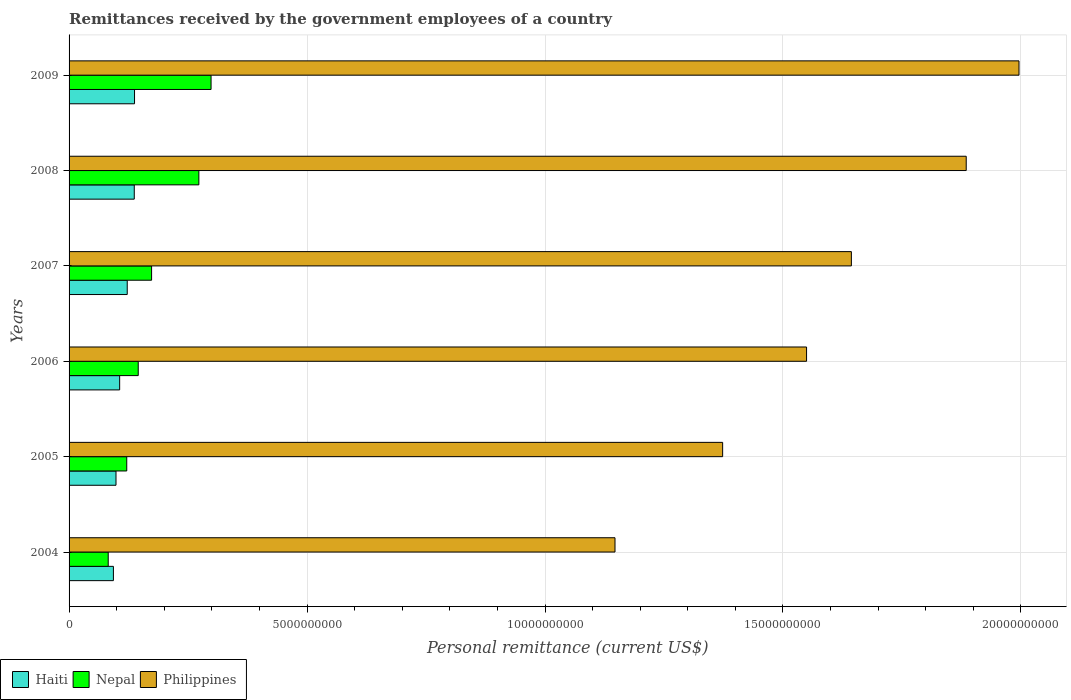Are the number of bars on each tick of the Y-axis equal?
Make the answer very short. Yes. How many bars are there on the 5th tick from the bottom?
Your answer should be compact. 3. What is the label of the 1st group of bars from the top?
Provide a short and direct response. 2009. What is the remittances received by the government employees in Philippines in 2005?
Offer a terse response. 1.37e+1. Across all years, what is the maximum remittances received by the government employees in Haiti?
Keep it short and to the point. 1.38e+09. Across all years, what is the minimum remittances received by the government employees in Haiti?
Give a very brief answer. 9.32e+08. In which year was the remittances received by the government employees in Philippines maximum?
Your answer should be very brief. 2009. In which year was the remittances received by the government employees in Philippines minimum?
Make the answer very short. 2004. What is the total remittances received by the government employees in Nepal in the graph?
Keep it short and to the point. 1.09e+1. What is the difference between the remittances received by the government employees in Haiti in 2007 and that in 2008?
Provide a succinct answer. -1.48e+08. What is the difference between the remittances received by the government employees in Haiti in 2006 and the remittances received by the government employees in Nepal in 2008?
Offer a very short reply. -1.66e+09. What is the average remittances received by the government employees in Nepal per year?
Give a very brief answer. 1.82e+09. In the year 2006, what is the difference between the remittances received by the government employees in Philippines and remittances received by the government employees in Haiti?
Make the answer very short. 1.44e+1. What is the ratio of the remittances received by the government employees in Nepal in 2005 to that in 2007?
Provide a short and direct response. 0.7. Is the difference between the remittances received by the government employees in Philippines in 2005 and 2009 greater than the difference between the remittances received by the government employees in Haiti in 2005 and 2009?
Offer a terse response. No. What is the difference between the highest and the second highest remittances received by the government employees in Haiti?
Provide a short and direct response. 5.79e+06. What is the difference between the highest and the lowest remittances received by the government employees in Nepal?
Make the answer very short. 2.16e+09. What does the 3rd bar from the top in 2006 represents?
Your response must be concise. Haiti. What does the 3rd bar from the bottom in 2004 represents?
Your answer should be compact. Philippines. How many bars are there?
Offer a terse response. 18. Are all the bars in the graph horizontal?
Provide a succinct answer. Yes. How many years are there in the graph?
Provide a succinct answer. 6. Where does the legend appear in the graph?
Provide a short and direct response. Bottom left. How are the legend labels stacked?
Your response must be concise. Horizontal. What is the title of the graph?
Offer a terse response. Remittances received by the government employees of a country. What is the label or title of the X-axis?
Your answer should be very brief. Personal remittance (current US$). What is the Personal remittance (current US$) of Haiti in 2004?
Provide a short and direct response. 9.32e+08. What is the Personal remittance (current US$) of Nepal in 2004?
Offer a terse response. 8.23e+08. What is the Personal remittance (current US$) of Philippines in 2004?
Provide a succinct answer. 1.15e+1. What is the Personal remittance (current US$) in Haiti in 2005?
Your response must be concise. 9.86e+08. What is the Personal remittance (current US$) in Nepal in 2005?
Provide a short and direct response. 1.21e+09. What is the Personal remittance (current US$) in Philippines in 2005?
Make the answer very short. 1.37e+1. What is the Personal remittance (current US$) of Haiti in 2006?
Your answer should be compact. 1.06e+09. What is the Personal remittance (current US$) of Nepal in 2006?
Keep it short and to the point. 1.45e+09. What is the Personal remittance (current US$) in Philippines in 2006?
Offer a very short reply. 1.55e+1. What is the Personal remittance (current US$) of Haiti in 2007?
Give a very brief answer. 1.22e+09. What is the Personal remittance (current US$) in Nepal in 2007?
Offer a very short reply. 1.73e+09. What is the Personal remittance (current US$) of Philippines in 2007?
Provide a short and direct response. 1.64e+1. What is the Personal remittance (current US$) in Haiti in 2008?
Offer a terse response. 1.37e+09. What is the Personal remittance (current US$) of Nepal in 2008?
Your answer should be compact. 2.73e+09. What is the Personal remittance (current US$) of Philippines in 2008?
Give a very brief answer. 1.89e+1. What is the Personal remittance (current US$) in Haiti in 2009?
Give a very brief answer. 1.38e+09. What is the Personal remittance (current US$) in Nepal in 2009?
Keep it short and to the point. 2.98e+09. What is the Personal remittance (current US$) in Philippines in 2009?
Provide a short and direct response. 2.00e+1. Across all years, what is the maximum Personal remittance (current US$) in Haiti?
Ensure brevity in your answer.  1.38e+09. Across all years, what is the maximum Personal remittance (current US$) in Nepal?
Offer a terse response. 2.98e+09. Across all years, what is the maximum Personal remittance (current US$) in Philippines?
Provide a succinct answer. 2.00e+1. Across all years, what is the minimum Personal remittance (current US$) of Haiti?
Your answer should be compact. 9.32e+08. Across all years, what is the minimum Personal remittance (current US$) in Nepal?
Make the answer very short. 8.23e+08. Across all years, what is the minimum Personal remittance (current US$) in Philippines?
Your answer should be very brief. 1.15e+1. What is the total Personal remittance (current US$) in Haiti in the graph?
Your answer should be very brief. 6.95e+09. What is the total Personal remittance (current US$) in Nepal in the graph?
Give a very brief answer. 1.09e+1. What is the total Personal remittance (current US$) of Philippines in the graph?
Give a very brief answer. 9.59e+1. What is the difference between the Personal remittance (current US$) in Haiti in 2004 and that in 2005?
Provide a succinct answer. -5.46e+07. What is the difference between the Personal remittance (current US$) in Nepal in 2004 and that in 2005?
Keep it short and to the point. -3.89e+08. What is the difference between the Personal remittance (current US$) in Philippines in 2004 and that in 2005?
Offer a terse response. -2.26e+09. What is the difference between the Personal remittance (current US$) in Haiti in 2004 and that in 2006?
Give a very brief answer. -1.31e+08. What is the difference between the Personal remittance (current US$) of Nepal in 2004 and that in 2006?
Give a very brief answer. -6.31e+08. What is the difference between the Personal remittance (current US$) of Philippines in 2004 and that in 2006?
Make the answer very short. -4.03e+09. What is the difference between the Personal remittance (current US$) in Haiti in 2004 and that in 2007?
Your answer should be compact. -2.91e+08. What is the difference between the Personal remittance (current US$) of Nepal in 2004 and that in 2007?
Ensure brevity in your answer.  -9.11e+08. What is the difference between the Personal remittance (current US$) of Philippines in 2004 and that in 2007?
Provide a succinct answer. -4.97e+09. What is the difference between the Personal remittance (current US$) of Haiti in 2004 and that in 2008?
Offer a very short reply. -4.38e+08. What is the difference between the Personal remittance (current US$) of Nepal in 2004 and that in 2008?
Offer a terse response. -1.90e+09. What is the difference between the Personal remittance (current US$) of Philippines in 2004 and that in 2008?
Ensure brevity in your answer.  -7.38e+09. What is the difference between the Personal remittance (current US$) in Haiti in 2004 and that in 2009?
Offer a very short reply. -4.44e+08. What is the difference between the Personal remittance (current US$) of Nepal in 2004 and that in 2009?
Your answer should be compact. -2.16e+09. What is the difference between the Personal remittance (current US$) in Philippines in 2004 and that in 2009?
Ensure brevity in your answer.  -8.49e+09. What is the difference between the Personal remittance (current US$) of Haiti in 2005 and that in 2006?
Ensure brevity in your answer.  -7.67e+07. What is the difference between the Personal remittance (current US$) of Nepal in 2005 and that in 2006?
Your answer should be very brief. -2.41e+08. What is the difference between the Personal remittance (current US$) of Philippines in 2005 and that in 2006?
Your answer should be very brief. -1.76e+09. What is the difference between the Personal remittance (current US$) in Haiti in 2005 and that in 2007?
Your answer should be very brief. -2.36e+08. What is the difference between the Personal remittance (current US$) in Nepal in 2005 and that in 2007?
Your response must be concise. -5.22e+08. What is the difference between the Personal remittance (current US$) of Philippines in 2005 and that in 2007?
Provide a short and direct response. -2.70e+09. What is the difference between the Personal remittance (current US$) in Haiti in 2005 and that in 2008?
Your answer should be very brief. -3.84e+08. What is the difference between the Personal remittance (current US$) of Nepal in 2005 and that in 2008?
Make the answer very short. -1.52e+09. What is the difference between the Personal remittance (current US$) of Philippines in 2005 and that in 2008?
Offer a very short reply. -5.12e+09. What is the difference between the Personal remittance (current US$) in Haiti in 2005 and that in 2009?
Your answer should be compact. -3.89e+08. What is the difference between the Personal remittance (current US$) of Nepal in 2005 and that in 2009?
Your answer should be very brief. -1.77e+09. What is the difference between the Personal remittance (current US$) of Philippines in 2005 and that in 2009?
Provide a succinct answer. -6.23e+09. What is the difference between the Personal remittance (current US$) in Haiti in 2006 and that in 2007?
Your answer should be very brief. -1.59e+08. What is the difference between the Personal remittance (current US$) in Nepal in 2006 and that in 2007?
Provide a short and direct response. -2.81e+08. What is the difference between the Personal remittance (current US$) in Philippines in 2006 and that in 2007?
Make the answer very short. -9.41e+08. What is the difference between the Personal remittance (current US$) in Haiti in 2006 and that in 2008?
Your response must be concise. -3.07e+08. What is the difference between the Personal remittance (current US$) in Nepal in 2006 and that in 2008?
Offer a very short reply. -1.27e+09. What is the difference between the Personal remittance (current US$) of Philippines in 2006 and that in 2008?
Keep it short and to the point. -3.35e+09. What is the difference between the Personal remittance (current US$) of Haiti in 2006 and that in 2009?
Your answer should be very brief. -3.13e+08. What is the difference between the Personal remittance (current US$) of Nepal in 2006 and that in 2009?
Offer a terse response. -1.53e+09. What is the difference between the Personal remittance (current US$) of Philippines in 2006 and that in 2009?
Offer a terse response. -4.46e+09. What is the difference between the Personal remittance (current US$) in Haiti in 2007 and that in 2008?
Offer a very short reply. -1.48e+08. What is the difference between the Personal remittance (current US$) of Nepal in 2007 and that in 2008?
Give a very brief answer. -9.93e+08. What is the difference between the Personal remittance (current US$) of Philippines in 2007 and that in 2008?
Offer a terse response. -2.41e+09. What is the difference between the Personal remittance (current US$) in Haiti in 2007 and that in 2009?
Offer a terse response. -1.53e+08. What is the difference between the Personal remittance (current US$) in Nepal in 2007 and that in 2009?
Make the answer very short. -1.25e+09. What is the difference between the Personal remittance (current US$) in Philippines in 2007 and that in 2009?
Your response must be concise. -3.52e+09. What is the difference between the Personal remittance (current US$) of Haiti in 2008 and that in 2009?
Provide a short and direct response. -5.79e+06. What is the difference between the Personal remittance (current US$) in Nepal in 2008 and that in 2009?
Keep it short and to the point. -2.56e+08. What is the difference between the Personal remittance (current US$) of Philippines in 2008 and that in 2009?
Your answer should be very brief. -1.11e+09. What is the difference between the Personal remittance (current US$) in Haiti in 2004 and the Personal remittance (current US$) in Nepal in 2005?
Provide a succinct answer. -2.80e+08. What is the difference between the Personal remittance (current US$) in Haiti in 2004 and the Personal remittance (current US$) in Philippines in 2005?
Provide a succinct answer. -1.28e+1. What is the difference between the Personal remittance (current US$) of Nepal in 2004 and the Personal remittance (current US$) of Philippines in 2005?
Keep it short and to the point. -1.29e+1. What is the difference between the Personal remittance (current US$) in Haiti in 2004 and the Personal remittance (current US$) in Nepal in 2006?
Offer a very short reply. -5.22e+08. What is the difference between the Personal remittance (current US$) of Haiti in 2004 and the Personal remittance (current US$) of Philippines in 2006?
Offer a terse response. -1.46e+1. What is the difference between the Personal remittance (current US$) in Nepal in 2004 and the Personal remittance (current US$) in Philippines in 2006?
Your answer should be very brief. -1.47e+1. What is the difference between the Personal remittance (current US$) of Haiti in 2004 and the Personal remittance (current US$) of Nepal in 2007?
Provide a succinct answer. -8.02e+08. What is the difference between the Personal remittance (current US$) of Haiti in 2004 and the Personal remittance (current US$) of Philippines in 2007?
Your response must be concise. -1.55e+1. What is the difference between the Personal remittance (current US$) of Nepal in 2004 and the Personal remittance (current US$) of Philippines in 2007?
Give a very brief answer. -1.56e+1. What is the difference between the Personal remittance (current US$) of Haiti in 2004 and the Personal remittance (current US$) of Nepal in 2008?
Your answer should be very brief. -1.80e+09. What is the difference between the Personal remittance (current US$) of Haiti in 2004 and the Personal remittance (current US$) of Philippines in 2008?
Keep it short and to the point. -1.79e+1. What is the difference between the Personal remittance (current US$) of Nepal in 2004 and the Personal remittance (current US$) of Philippines in 2008?
Make the answer very short. -1.80e+1. What is the difference between the Personal remittance (current US$) of Haiti in 2004 and the Personal remittance (current US$) of Nepal in 2009?
Keep it short and to the point. -2.05e+09. What is the difference between the Personal remittance (current US$) of Haiti in 2004 and the Personal remittance (current US$) of Philippines in 2009?
Make the answer very short. -1.90e+1. What is the difference between the Personal remittance (current US$) in Nepal in 2004 and the Personal remittance (current US$) in Philippines in 2009?
Ensure brevity in your answer.  -1.91e+1. What is the difference between the Personal remittance (current US$) of Haiti in 2005 and the Personal remittance (current US$) of Nepal in 2006?
Provide a succinct answer. -4.67e+08. What is the difference between the Personal remittance (current US$) in Haiti in 2005 and the Personal remittance (current US$) in Philippines in 2006?
Offer a terse response. -1.45e+1. What is the difference between the Personal remittance (current US$) in Nepal in 2005 and the Personal remittance (current US$) in Philippines in 2006?
Your response must be concise. -1.43e+1. What is the difference between the Personal remittance (current US$) of Haiti in 2005 and the Personal remittance (current US$) of Nepal in 2007?
Your answer should be compact. -7.48e+08. What is the difference between the Personal remittance (current US$) in Haiti in 2005 and the Personal remittance (current US$) in Philippines in 2007?
Keep it short and to the point. -1.55e+1. What is the difference between the Personal remittance (current US$) in Nepal in 2005 and the Personal remittance (current US$) in Philippines in 2007?
Provide a short and direct response. -1.52e+1. What is the difference between the Personal remittance (current US$) in Haiti in 2005 and the Personal remittance (current US$) in Nepal in 2008?
Offer a terse response. -1.74e+09. What is the difference between the Personal remittance (current US$) in Haiti in 2005 and the Personal remittance (current US$) in Philippines in 2008?
Ensure brevity in your answer.  -1.79e+1. What is the difference between the Personal remittance (current US$) of Nepal in 2005 and the Personal remittance (current US$) of Philippines in 2008?
Offer a very short reply. -1.76e+1. What is the difference between the Personal remittance (current US$) of Haiti in 2005 and the Personal remittance (current US$) of Nepal in 2009?
Your answer should be compact. -2.00e+09. What is the difference between the Personal remittance (current US$) of Haiti in 2005 and the Personal remittance (current US$) of Philippines in 2009?
Provide a succinct answer. -1.90e+1. What is the difference between the Personal remittance (current US$) in Nepal in 2005 and the Personal remittance (current US$) in Philippines in 2009?
Make the answer very short. -1.87e+1. What is the difference between the Personal remittance (current US$) in Haiti in 2006 and the Personal remittance (current US$) in Nepal in 2007?
Ensure brevity in your answer.  -6.71e+08. What is the difference between the Personal remittance (current US$) of Haiti in 2006 and the Personal remittance (current US$) of Philippines in 2007?
Make the answer very short. -1.54e+1. What is the difference between the Personal remittance (current US$) in Nepal in 2006 and the Personal remittance (current US$) in Philippines in 2007?
Provide a succinct answer. -1.50e+1. What is the difference between the Personal remittance (current US$) in Haiti in 2006 and the Personal remittance (current US$) in Nepal in 2008?
Offer a very short reply. -1.66e+09. What is the difference between the Personal remittance (current US$) of Haiti in 2006 and the Personal remittance (current US$) of Philippines in 2008?
Offer a very short reply. -1.78e+1. What is the difference between the Personal remittance (current US$) in Nepal in 2006 and the Personal remittance (current US$) in Philippines in 2008?
Provide a short and direct response. -1.74e+1. What is the difference between the Personal remittance (current US$) of Haiti in 2006 and the Personal remittance (current US$) of Nepal in 2009?
Give a very brief answer. -1.92e+09. What is the difference between the Personal remittance (current US$) of Haiti in 2006 and the Personal remittance (current US$) of Philippines in 2009?
Provide a succinct answer. -1.89e+1. What is the difference between the Personal remittance (current US$) of Nepal in 2006 and the Personal remittance (current US$) of Philippines in 2009?
Offer a very short reply. -1.85e+1. What is the difference between the Personal remittance (current US$) in Haiti in 2007 and the Personal remittance (current US$) in Nepal in 2008?
Your answer should be compact. -1.51e+09. What is the difference between the Personal remittance (current US$) in Haiti in 2007 and the Personal remittance (current US$) in Philippines in 2008?
Provide a succinct answer. -1.76e+1. What is the difference between the Personal remittance (current US$) of Nepal in 2007 and the Personal remittance (current US$) of Philippines in 2008?
Make the answer very short. -1.71e+1. What is the difference between the Personal remittance (current US$) of Haiti in 2007 and the Personal remittance (current US$) of Nepal in 2009?
Offer a very short reply. -1.76e+09. What is the difference between the Personal remittance (current US$) of Haiti in 2007 and the Personal remittance (current US$) of Philippines in 2009?
Give a very brief answer. -1.87e+1. What is the difference between the Personal remittance (current US$) of Nepal in 2007 and the Personal remittance (current US$) of Philippines in 2009?
Your response must be concise. -1.82e+1. What is the difference between the Personal remittance (current US$) of Haiti in 2008 and the Personal remittance (current US$) of Nepal in 2009?
Your response must be concise. -1.61e+09. What is the difference between the Personal remittance (current US$) of Haiti in 2008 and the Personal remittance (current US$) of Philippines in 2009?
Your answer should be very brief. -1.86e+1. What is the difference between the Personal remittance (current US$) in Nepal in 2008 and the Personal remittance (current US$) in Philippines in 2009?
Your answer should be compact. -1.72e+1. What is the average Personal remittance (current US$) in Haiti per year?
Your response must be concise. 1.16e+09. What is the average Personal remittance (current US$) of Nepal per year?
Give a very brief answer. 1.82e+09. What is the average Personal remittance (current US$) in Philippines per year?
Offer a terse response. 1.60e+1. In the year 2004, what is the difference between the Personal remittance (current US$) of Haiti and Personal remittance (current US$) of Nepal?
Ensure brevity in your answer.  1.09e+08. In the year 2004, what is the difference between the Personal remittance (current US$) of Haiti and Personal remittance (current US$) of Philippines?
Offer a terse response. -1.05e+1. In the year 2004, what is the difference between the Personal remittance (current US$) of Nepal and Personal remittance (current US$) of Philippines?
Your response must be concise. -1.06e+1. In the year 2005, what is the difference between the Personal remittance (current US$) in Haiti and Personal remittance (current US$) in Nepal?
Make the answer very short. -2.26e+08. In the year 2005, what is the difference between the Personal remittance (current US$) in Haiti and Personal remittance (current US$) in Philippines?
Your answer should be compact. -1.27e+1. In the year 2005, what is the difference between the Personal remittance (current US$) in Nepal and Personal remittance (current US$) in Philippines?
Provide a short and direct response. -1.25e+1. In the year 2006, what is the difference between the Personal remittance (current US$) in Haiti and Personal remittance (current US$) in Nepal?
Your answer should be very brief. -3.90e+08. In the year 2006, what is the difference between the Personal remittance (current US$) in Haiti and Personal remittance (current US$) in Philippines?
Provide a short and direct response. -1.44e+1. In the year 2006, what is the difference between the Personal remittance (current US$) in Nepal and Personal remittance (current US$) in Philippines?
Offer a very short reply. -1.40e+1. In the year 2007, what is the difference between the Personal remittance (current US$) in Haiti and Personal remittance (current US$) in Nepal?
Keep it short and to the point. -5.12e+08. In the year 2007, what is the difference between the Personal remittance (current US$) in Haiti and Personal remittance (current US$) in Philippines?
Make the answer very short. -1.52e+1. In the year 2007, what is the difference between the Personal remittance (current US$) of Nepal and Personal remittance (current US$) of Philippines?
Provide a short and direct response. -1.47e+1. In the year 2008, what is the difference between the Personal remittance (current US$) of Haiti and Personal remittance (current US$) of Nepal?
Make the answer very short. -1.36e+09. In the year 2008, what is the difference between the Personal remittance (current US$) in Haiti and Personal remittance (current US$) in Philippines?
Provide a succinct answer. -1.75e+1. In the year 2008, what is the difference between the Personal remittance (current US$) in Nepal and Personal remittance (current US$) in Philippines?
Your answer should be very brief. -1.61e+1. In the year 2009, what is the difference between the Personal remittance (current US$) in Haiti and Personal remittance (current US$) in Nepal?
Your response must be concise. -1.61e+09. In the year 2009, what is the difference between the Personal remittance (current US$) in Haiti and Personal remittance (current US$) in Philippines?
Offer a terse response. -1.86e+1. In the year 2009, what is the difference between the Personal remittance (current US$) in Nepal and Personal remittance (current US$) in Philippines?
Your response must be concise. -1.70e+1. What is the ratio of the Personal remittance (current US$) in Haiti in 2004 to that in 2005?
Your answer should be very brief. 0.94. What is the ratio of the Personal remittance (current US$) in Nepal in 2004 to that in 2005?
Provide a short and direct response. 0.68. What is the ratio of the Personal remittance (current US$) in Philippines in 2004 to that in 2005?
Keep it short and to the point. 0.84. What is the ratio of the Personal remittance (current US$) of Haiti in 2004 to that in 2006?
Offer a terse response. 0.88. What is the ratio of the Personal remittance (current US$) in Nepal in 2004 to that in 2006?
Make the answer very short. 0.57. What is the ratio of the Personal remittance (current US$) in Philippines in 2004 to that in 2006?
Give a very brief answer. 0.74. What is the ratio of the Personal remittance (current US$) of Haiti in 2004 to that in 2007?
Your answer should be compact. 0.76. What is the ratio of the Personal remittance (current US$) of Nepal in 2004 to that in 2007?
Ensure brevity in your answer.  0.47. What is the ratio of the Personal remittance (current US$) in Philippines in 2004 to that in 2007?
Keep it short and to the point. 0.7. What is the ratio of the Personal remittance (current US$) of Haiti in 2004 to that in 2008?
Your response must be concise. 0.68. What is the ratio of the Personal remittance (current US$) in Nepal in 2004 to that in 2008?
Ensure brevity in your answer.  0.3. What is the ratio of the Personal remittance (current US$) of Philippines in 2004 to that in 2008?
Provide a succinct answer. 0.61. What is the ratio of the Personal remittance (current US$) in Haiti in 2004 to that in 2009?
Provide a succinct answer. 0.68. What is the ratio of the Personal remittance (current US$) in Nepal in 2004 to that in 2009?
Your answer should be compact. 0.28. What is the ratio of the Personal remittance (current US$) in Philippines in 2004 to that in 2009?
Your answer should be very brief. 0.57. What is the ratio of the Personal remittance (current US$) of Haiti in 2005 to that in 2006?
Offer a terse response. 0.93. What is the ratio of the Personal remittance (current US$) of Nepal in 2005 to that in 2006?
Give a very brief answer. 0.83. What is the ratio of the Personal remittance (current US$) of Philippines in 2005 to that in 2006?
Your answer should be very brief. 0.89. What is the ratio of the Personal remittance (current US$) in Haiti in 2005 to that in 2007?
Your answer should be compact. 0.81. What is the ratio of the Personal remittance (current US$) of Nepal in 2005 to that in 2007?
Provide a succinct answer. 0.7. What is the ratio of the Personal remittance (current US$) in Philippines in 2005 to that in 2007?
Provide a succinct answer. 0.84. What is the ratio of the Personal remittance (current US$) in Haiti in 2005 to that in 2008?
Keep it short and to the point. 0.72. What is the ratio of the Personal remittance (current US$) of Nepal in 2005 to that in 2008?
Keep it short and to the point. 0.44. What is the ratio of the Personal remittance (current US$) of Philippines in 2005 to that in 2008?
Offer a very short reply. 0.73. What is the ratio of the Personal remittance (current US$) of Haiti in 2005 to that in 2009?
Offer a terse response. 0.72. What is the ratio of the Personal remittance (current US$) in Nepal in 2005 to that in 2009?
Keep it short and to the point. 0.41. What is the ratio of the Personal remittance (current US$) of Philippines in 2005 to that in 2009?
Your response must be concise. 0.69. What is the ratio of the Personal remittance (current US$) of Haiti in 2006 to that in 2007?
Keep it short and to the point. 0.87. What is the ratio of the Personal remittance (current US$) in Nepal in 2006 to that in 2007?
Make the answer very short. 0.84. What is the ratio of the Personal remittance (current US$) in Philippines in 2006 to that in 2007?
Keep it short and to the point. 0.94. What is the ratio of the Personal remittance (current US$) of Haiti in 2006 to that in 2008?
Your answer should be very brief. 0.78. What is the ratio of the Personal remittance (current US$) in Nepal in 2006 to that in 2008?
Keep it short and to the point. 0.53. What is the ratio of the Personal remittance (current US$) of Philippines in 2006 to that in 2008?
Your answer should be compact. 0.82. What is the ratio of the Personal remittance (current US$) in Haiti in 2006 to that in 2009?
Offer a very short reply. 0.77. What is the ratio of the Personal remittance (current US$) of Nepal in 2006 to that in 2009?
Provide a short and direct response. 0.49. What is the ratio of the Personal remittance (current US$) in Philippines in 2006 to that in 2009?
Provide a short and direct response. 0.78. What is the ratio of the Personal remittance (current US$) in Haiti in 2007 to that in 2008?
Provide a short and direct response. 0.89. What is the ratio of the Personal remittance (current US$) in Nepal in 2007 to that in 2008?
Offer a terse response. 0.64. What is the ratio of the Personal remittance (current US$) in Philippines in 2007 to that in 2008?
Keep it short and to the point. 0.87. What is the ratio of the Personal remittance (current US$) of Haiti in 2007 to that in 2009?
Give a very brief answer. 0.89. What is the ratio of the Personal remittance (current US$) in Nepal in 2007 to that in 2009?
Ensure brevity in your answer.  0.58. What is the ratio of the Personal remittance (current US$) of Philippines in 2007 to that in 2009?
Provide a short and direct response. 0.82. What is the ratio of the Personal remittance (current US$) of Nepal in 2008 to that in 2009?
Your answer should be compact. 0.91. What is the difference between the highest and the second highest Personal remittance (current US$) of Haiti?
Your answer should be compact. 5.79e+06. What is the difference between the highest and the second highest Personal remittance (current US$) in Nepal?
Offer a very short reply. 2.56e+08. What is the difference between the highest and the second highest Personal remittance (current US$) in Philippines?
Your response must be concise. 1.11e+09. What is the difference between the highest and the lowest Personal remittance (current US$) in Haiti?
Your answer should be very brief. 4.44e+08. What is the difference between the highest and the lowest Personal remittance (current US$) of Nepal?
Give a very brief answer. 2.16e+09. What is the difference between the highest and the lowest Personal remittance (current US$) of Philippines?
Offer a very short reply. 8.49e+09. 